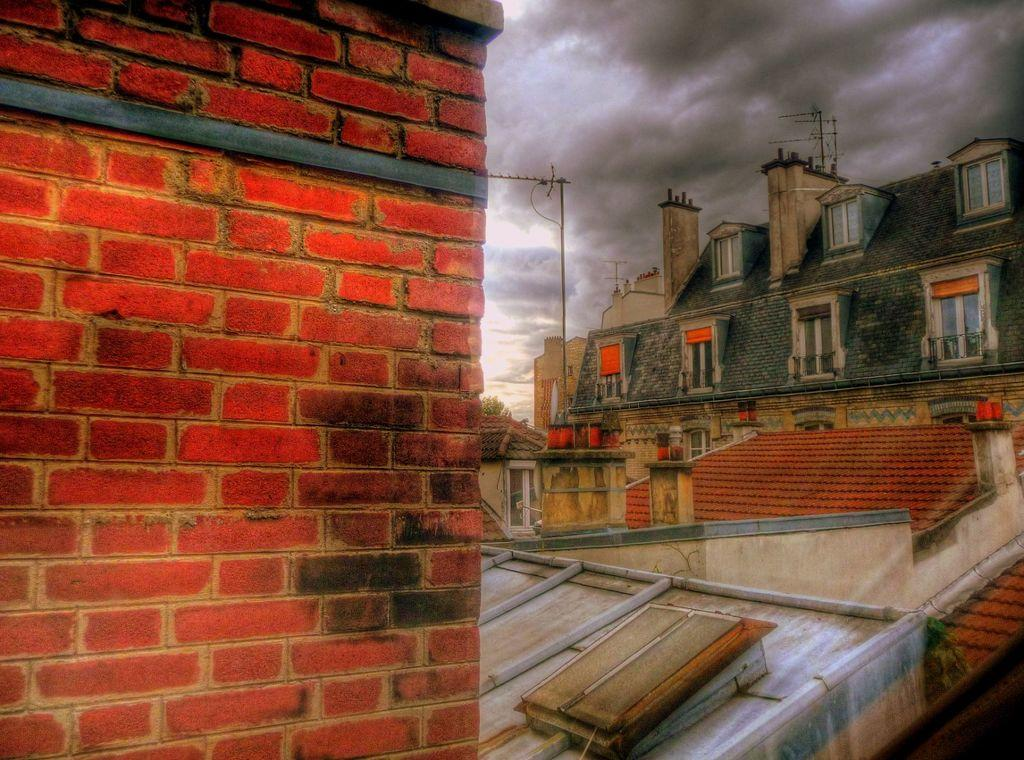What type of structures can be seen in the image? There are buildings with windows in the image. What other objects are present in the image? There are poles and a wall in the image. What can be seen in the background of the image? The sky with clouds is visible in the background of the image. How many toads are sitting on the wall in the image? There are no toads present in the image; it only features buildings, poles, a wall, and the sky with clouds. 